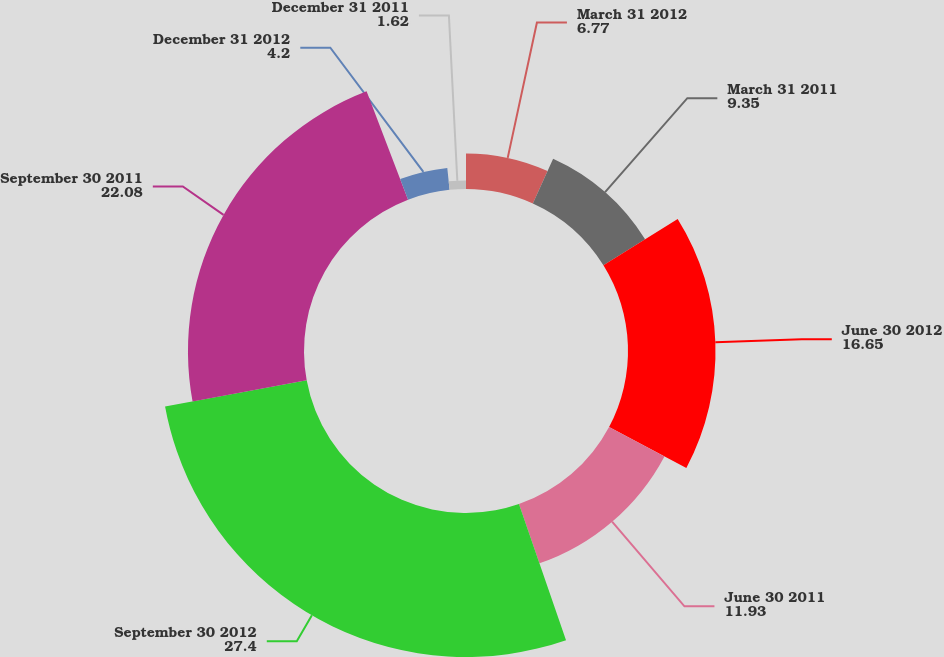<chart> <loc_0><loc_0><loc_500><loc_500><pie_chart><fcel>March 31 2012<fcel>March 31 2011<fcel>June 30 2012<fcel>June 30 2011<fcel>September 30 2012<fcel>September 30 2011<fcel>December 31 2012<fcel>December 31 2011<nl><fcel>6.77%<fcel>9.35%<fcel>16.65%<fcel>11.93%<fcel>27.4%<fcel>22.08%<fcel>4.2%<fcel>1.62%<nl></chart> 